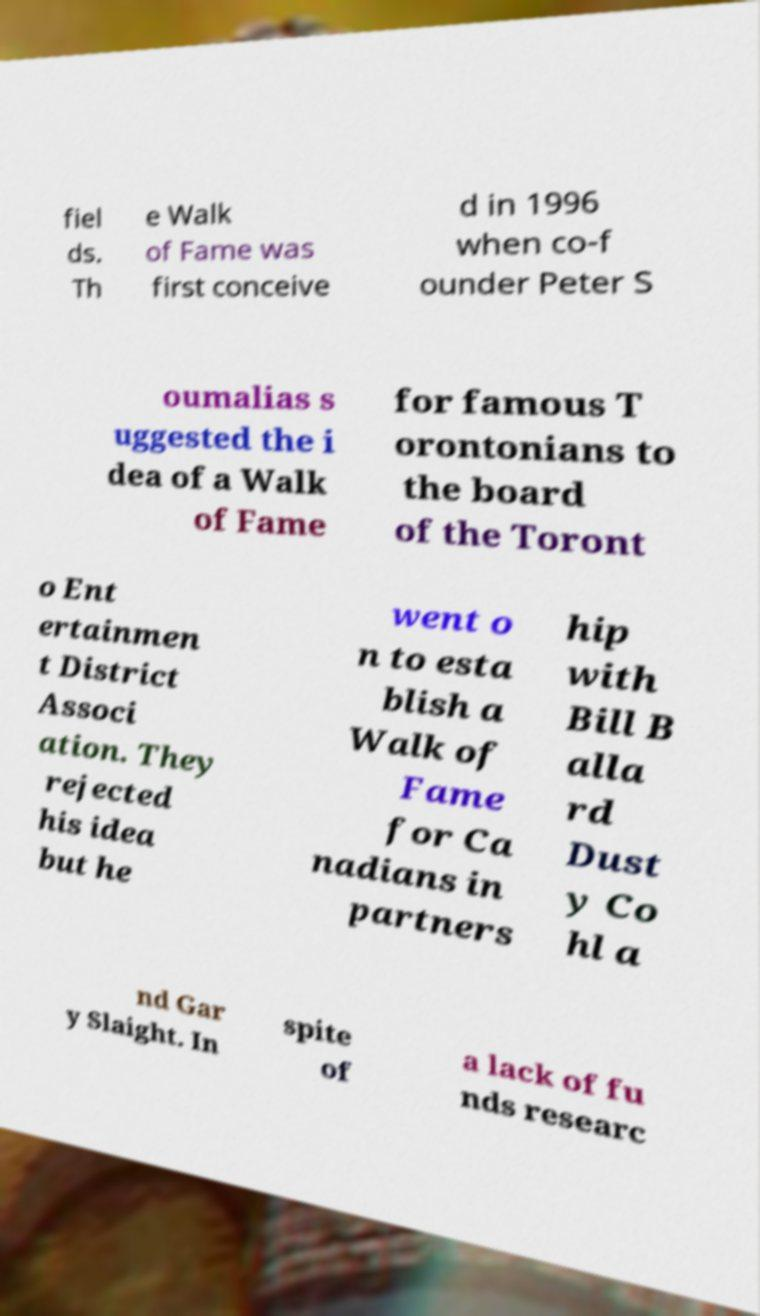Please read and relay the text visible in this image. What does it say? fiel ds. Th e Walk of Fame was first conceive d in 1996 when co-f ounder Peter S oumalias s uggested the i dea of a Walk of Fame for famous T orontonians to the board of the Toront o Ent ertainmen t District Associ ation. They rejected his idea but he went o n to esta blish a Walk of Fame for Ca nadians in partners hip with Bill B alla rd Dust y Co hl a nd Gar y Slaight. In spite of a lack of fu nds researc 